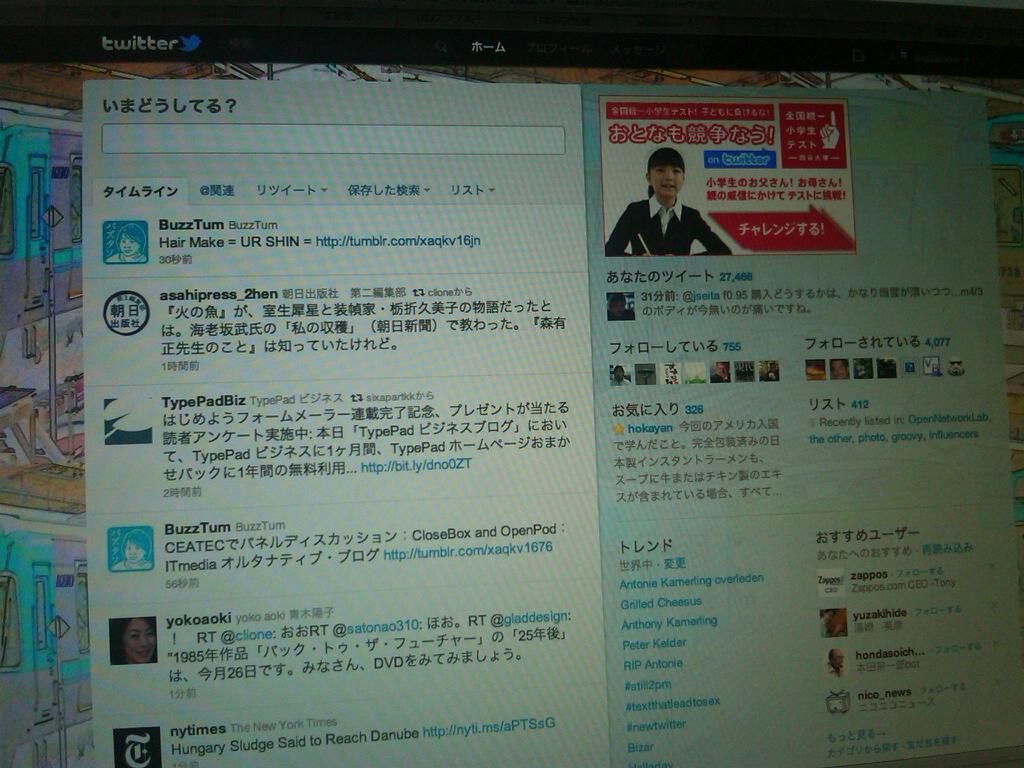<image>
Relay a brief, clear account of the picture shown. A online website which contains nytimes at the bottom. 